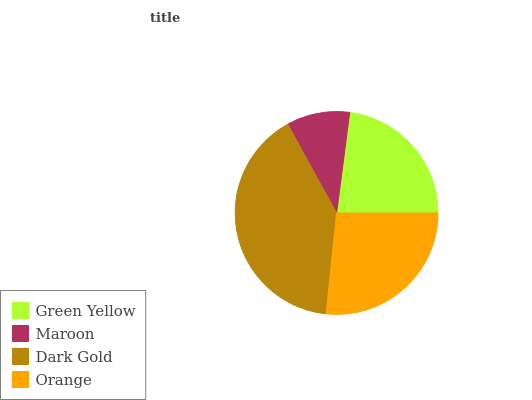Is Maroon the minimum?
Answer yes or no. Yes. Is Dark Gold the maximum?
Answer yes or no. Yes. Is Dark Gold the minimum?
Answer yes or no. No. Is Maroon the maximum?
Answer yes or no. No. Is Dark Gold greater than Maroon?
Answer yes or no. Yes. Is Maroon less than Dark Gold?
Answer yes or no. Yes. Is Maroon greater than Dark Gold?
Answer yes or no. No. Is Dark Gold less than Maroon?
Answer yes or no. No. Is Orange the high median?
Answer yes or no. Yes. Is Green Yellow the low median?
Answer yes or no. Yes. Is Dark Gold the high median?
Answer yes or no. No. Is Dark Gold the low median?
Answer yes or no. No. 